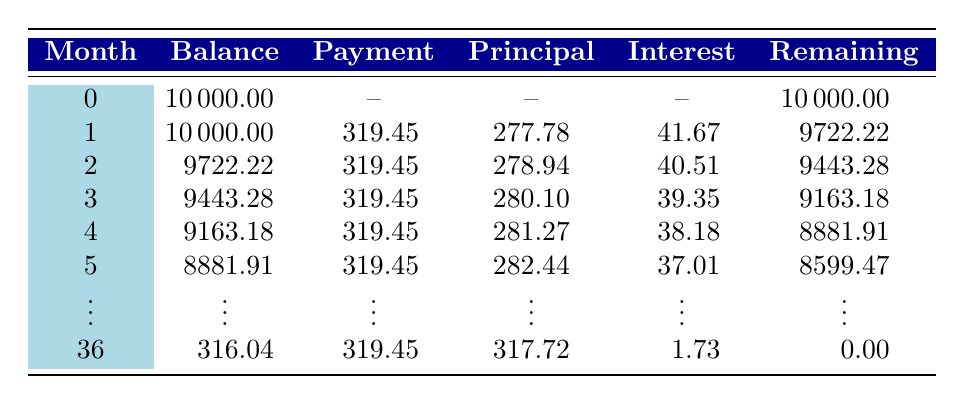What is the total amount of the loan taken for the music class? The loan amount is explicitly stated in the table as 10000.
Answer: 10000 What is the monthly payment made towards the loan in the first month? In the first month, the table shows that the total payment is 319.45.
Answer: 319.45 How much of the first month's payment goes towards the principal? The first month's payment towards the principal is specifically listed in the table as 277.78.
Answer: 277.78 What is the cumulative surplus after 12 months? According to the break-even analysis in the table, the cumulative surplus after 12 months is 4000.
Answer: 4000 Is the instructor's salary per month greater than the total revenue generated per month? The instructor's salary per month is 2000 while the total revenue per month from tuition fees is 3000, therefore, the statement is false.
Answer: No What is the remaining balance after the third month? After the third month, the table indicates the remaining balance is 9163.18.
Answer: 9163.18 How much interest is paid in the second month? In the second month, the interest paid is shown as 40.51 in the table.
Answer: 40.51 What is the difference between the total revenue and total expenses for the first month? The total revenue for the first month is 3000, while the total expenses (instructor salary 2000 + venue rental 500 + materials 200 + marketing 300 = 3000) equal 3000, so the difference is 3000 - 3000 = 0.
Answer: 0 In which month does the class break even? The break-even analysis states that the breakeven point is reached at 5 months.
Answer: 5 